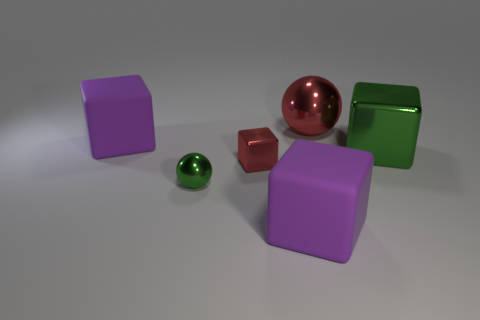Is the number of purple matte blocks in front of the big red shiny ball the same as the number of green metallic cubes?
Make the answer very short. No. What number of cylinders are either shiny objects or small red metallic things?
Provide a short and direct response. 0. The small block that is the same material as the large ball is what color?
Keep it short and to the point. Red. Is the material of the tiny red object the same as the sphere that is right of the small metal block?
Your answer should be compact. Yes. How many things are either large yellow rubber cylinders or balls?
Offer a very short reply. 2. There is a tiny object that is the same color as the big metal block; what is it made of?
Offer a very short reply. Metal. Are there any other things of the same shape as the tiny red object?
Your answer should be compact. Yes. There is a tiny cube; how many large rubber things are right of it?
Offer a very short reply. 1. What material is the green object to the right of the large metal thing behind the large metal block?
Your answer should be very brief. Metal. Are there any green spheres of the same size as the red metallic cube?
Give a very brief answer. Yes. 